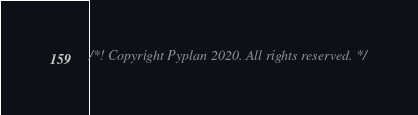Convert code to text. <code><loc_0><loc_0><loc_500><loc_500><_JavaScript_>/*! Copyright Pyplan 2020. All rights reserved. */</code> 